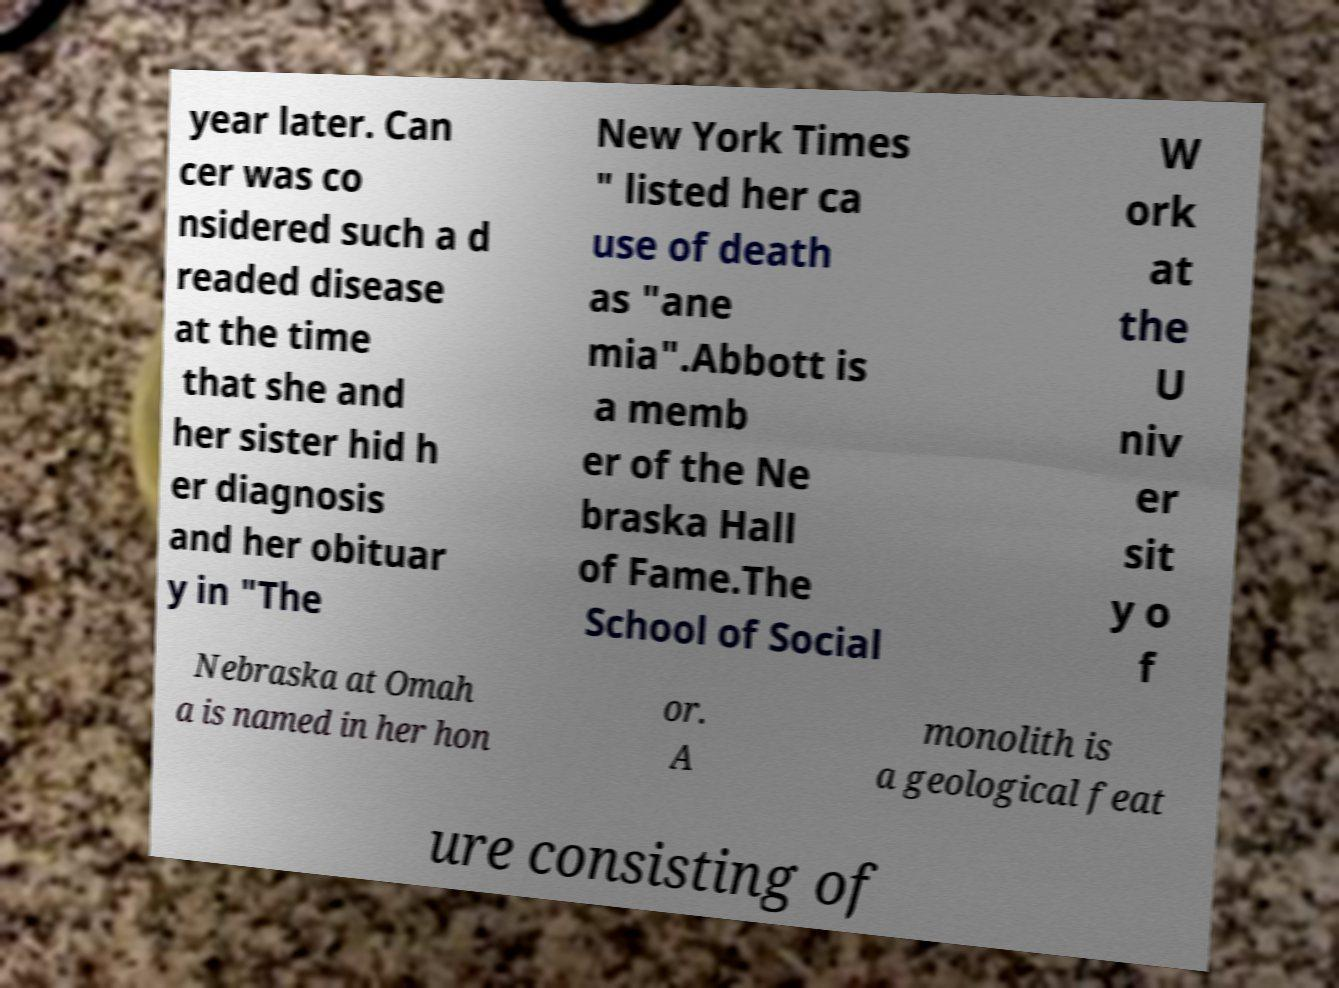Can you read and provide the text displayed in the image?This photo seems to have some interesting text. Can you extract and type it out for me? year later. Can cer was co nsidered such a d readed disease at the time that she and her sister hid h er diagnosis and her obituar y in "The New York Times " listed her ca use of death as "ane mia".Abbott is a memb er of the Ne braska Hall of Fame.The School of Social W ork at the U niv er sit y o f Nebraska at Omah a is named in her hon or. A monolith is a geological feat ure consisting of 